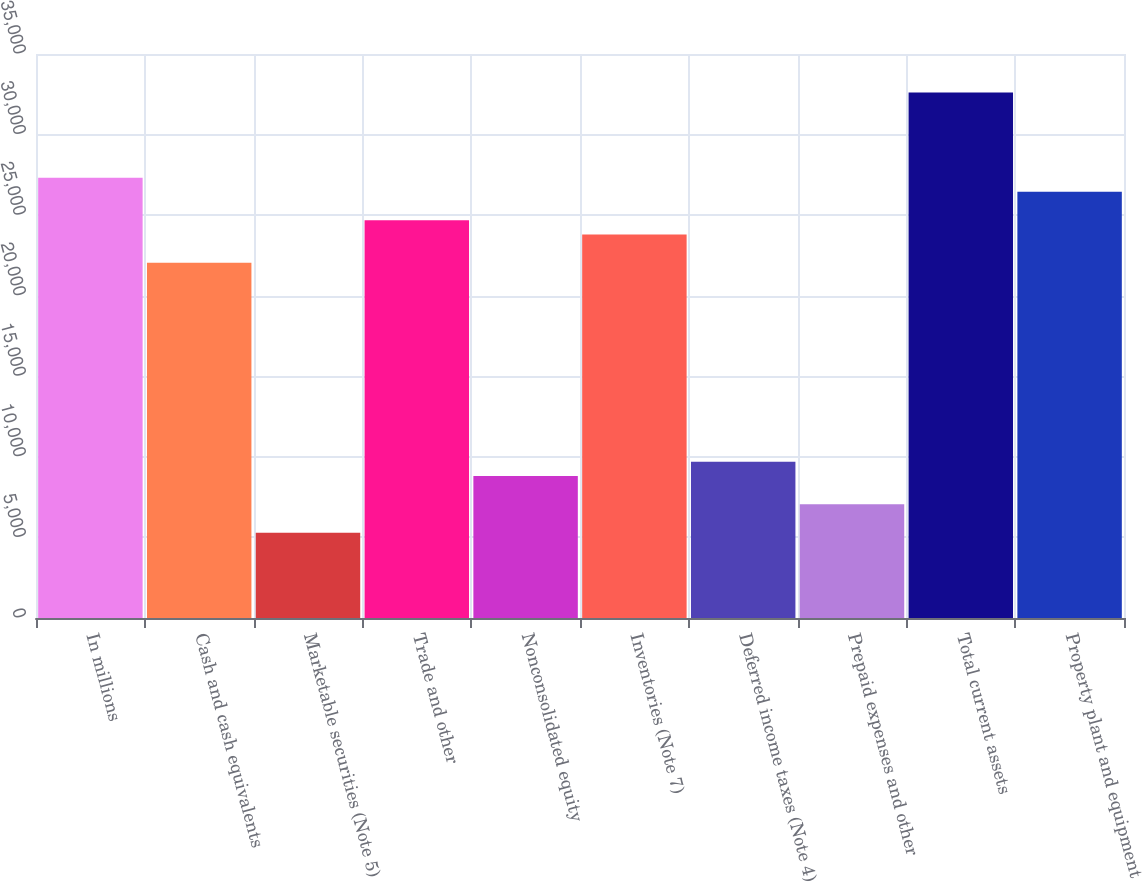Convert chart. <chart><loc_0><loc_0><loc_500><loc_500><bar_chart><fcel>In millions<fcel>Cash and cash equivalents<fcel>Marketable securities (Note 5)<fcel>Trade and other<fcel>Nonconsolidated equity<fcel>Inventories (Note 7)<fcel>Deferred income taxes (Note 4)<fcel>Prepaid expenses and other<fcel>Total current assets<fcel>Property plant and equipment<nl><fcel>27327.5<fcel>22038.5<fcel>5290<fcel>24683<fcel>8816<fcel>23801.5<fcel>9697.5<fcel>7053<fcel>32616.5<fcel>26446<nl></chart> 